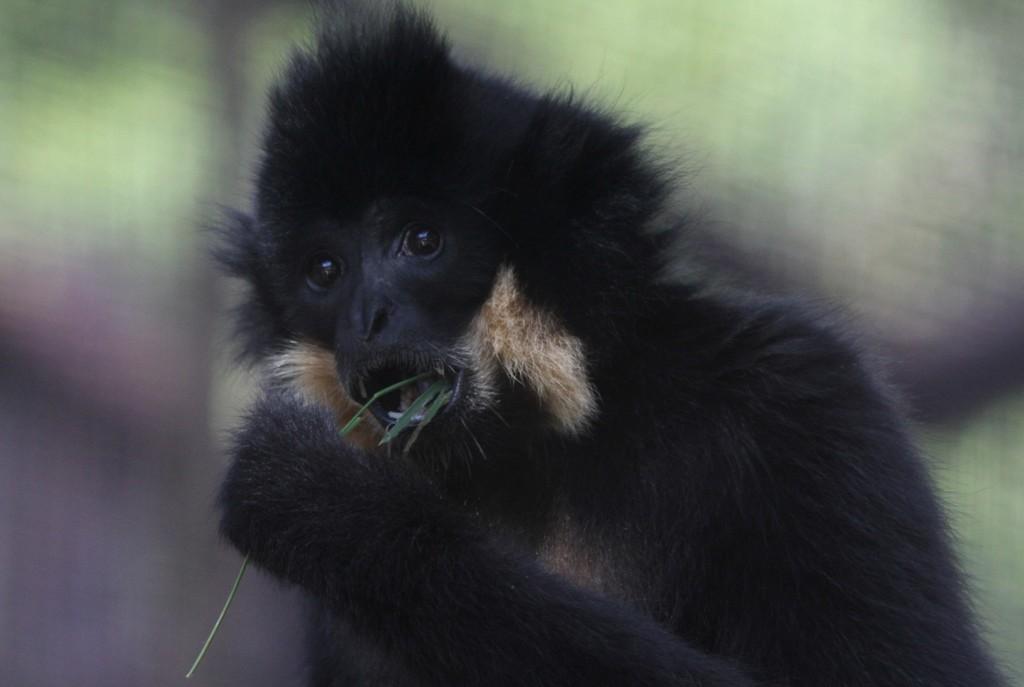Please provide a concise description of this image. In this picture I can see a chimpanzee in the middle, it is in black color. 